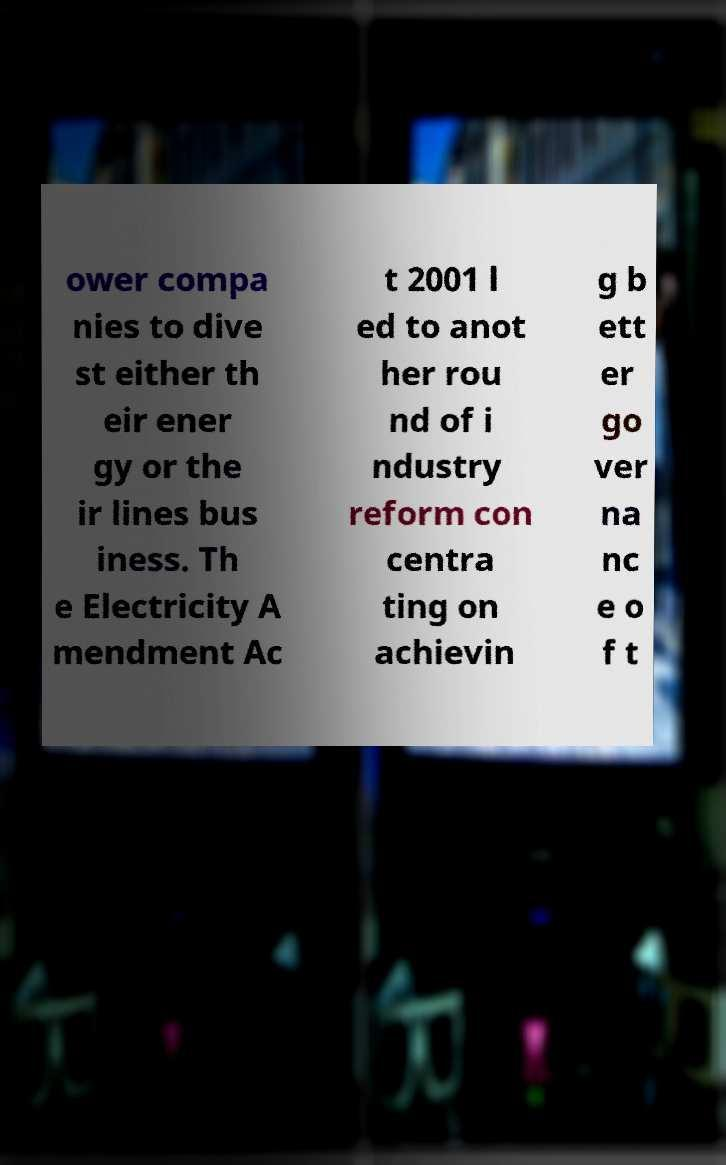I need the written content from this picture converted into text. Can you do that? ower compa nies to dive st either th eir ener gy or the ir lines bus iness. Th e Electricity A mendment Ac t 2001 l ed to anot her rou nd of i ndustry reform con centra ting on achievin g b ett er go ver na nc e o f t 